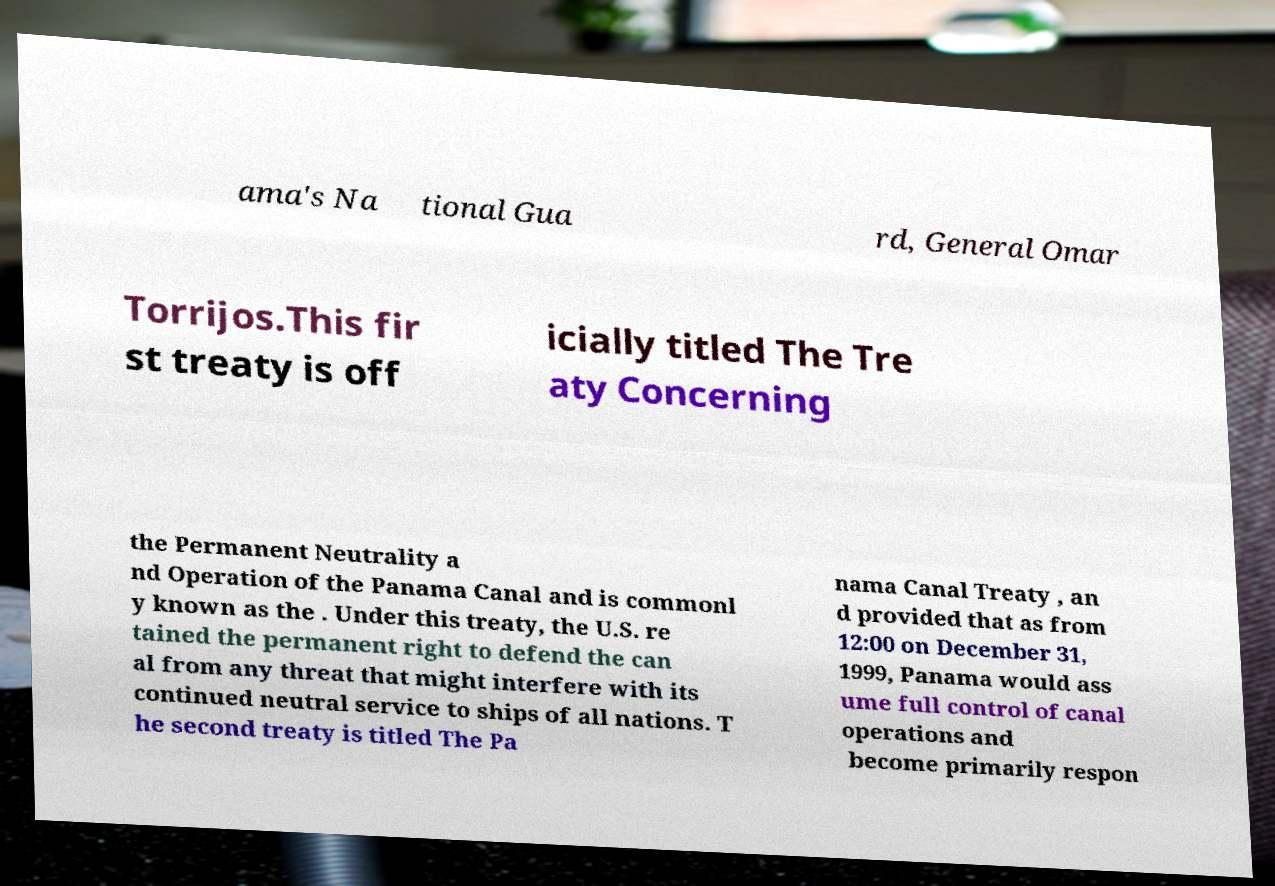I need the written content from this picture converted into text. Can you do that? ama's Na tional Gua rd, General Omar Torrijos.This fir st treaty is off icially titled The Tre aty Concerning the Permanent Neutrality a nd Operation of the Panama Canal and is commonl y known as the . Under this treaty, the U.S. re tained the permanent right to defend the can al from any threat that might interfere with its continued neutral service to ships of all nations. T he second treaty is titled The Pa nama Canal Treaty , an d provided that as from 12:00 on December 31, 1999, Panama would ass ume full control of canal operations and become primarily respon 